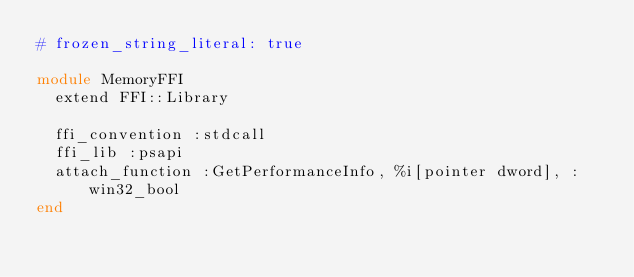Convert code to text. <code><loc_0><loc_0><loc_500><loc_500><_Ruby_># frozen_string_literal: true

module MemoryFFI
  extend FFI::Library

  ffi_convention :stdcall
  ffi_lib :psapi
  attach_function :GetPerformanceInfo, %i[pointer dword], :win32_bool
end
</code> 